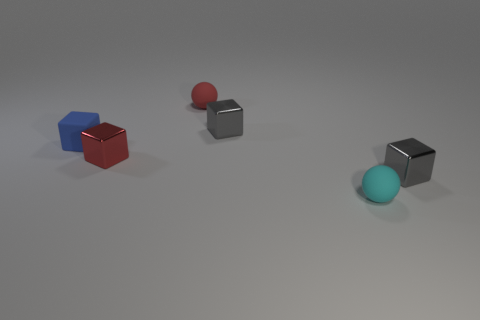Is the size of the red sphere the same as the sphere in front of the red sphere?
Ensure brevity in your answer.  Yes. There is a rubber sphere that is behind the blue matte block; is it the same size as the tiny blue cube?
Your answer should be compact. Yes. Are there an equal number of tiny matte things to the left of the small cyan ball and tiny gray things in front of the blue matte object?
Offer a terse response. No. The tiny metal cube that is on the right side of the rubber thing in front of the tiny gray cube right of the cyan rubber object is what color?
Your answer should be very brief. Gray. What shape is the red thing in front of the blue cube?
Make the answer very short. Cube. The red thing that is the same material as the blue cube is what shape?
Your answer should be compact. Sphere. Are there any other things that have the same shape as the cyan object?
Ensure brevity in your answer.  Yes. How many tiny cubes are in front of the small blue object?
Offer a very short reply. 2. Is the number of small cyan spheres that are behind the red ball the same as the number of large shiny cylinders?
Your response must be concise. Yes. Does the tiny blue object have the same material as the small cyan sphere?
Ensure brevity in your answer.  Yes. 